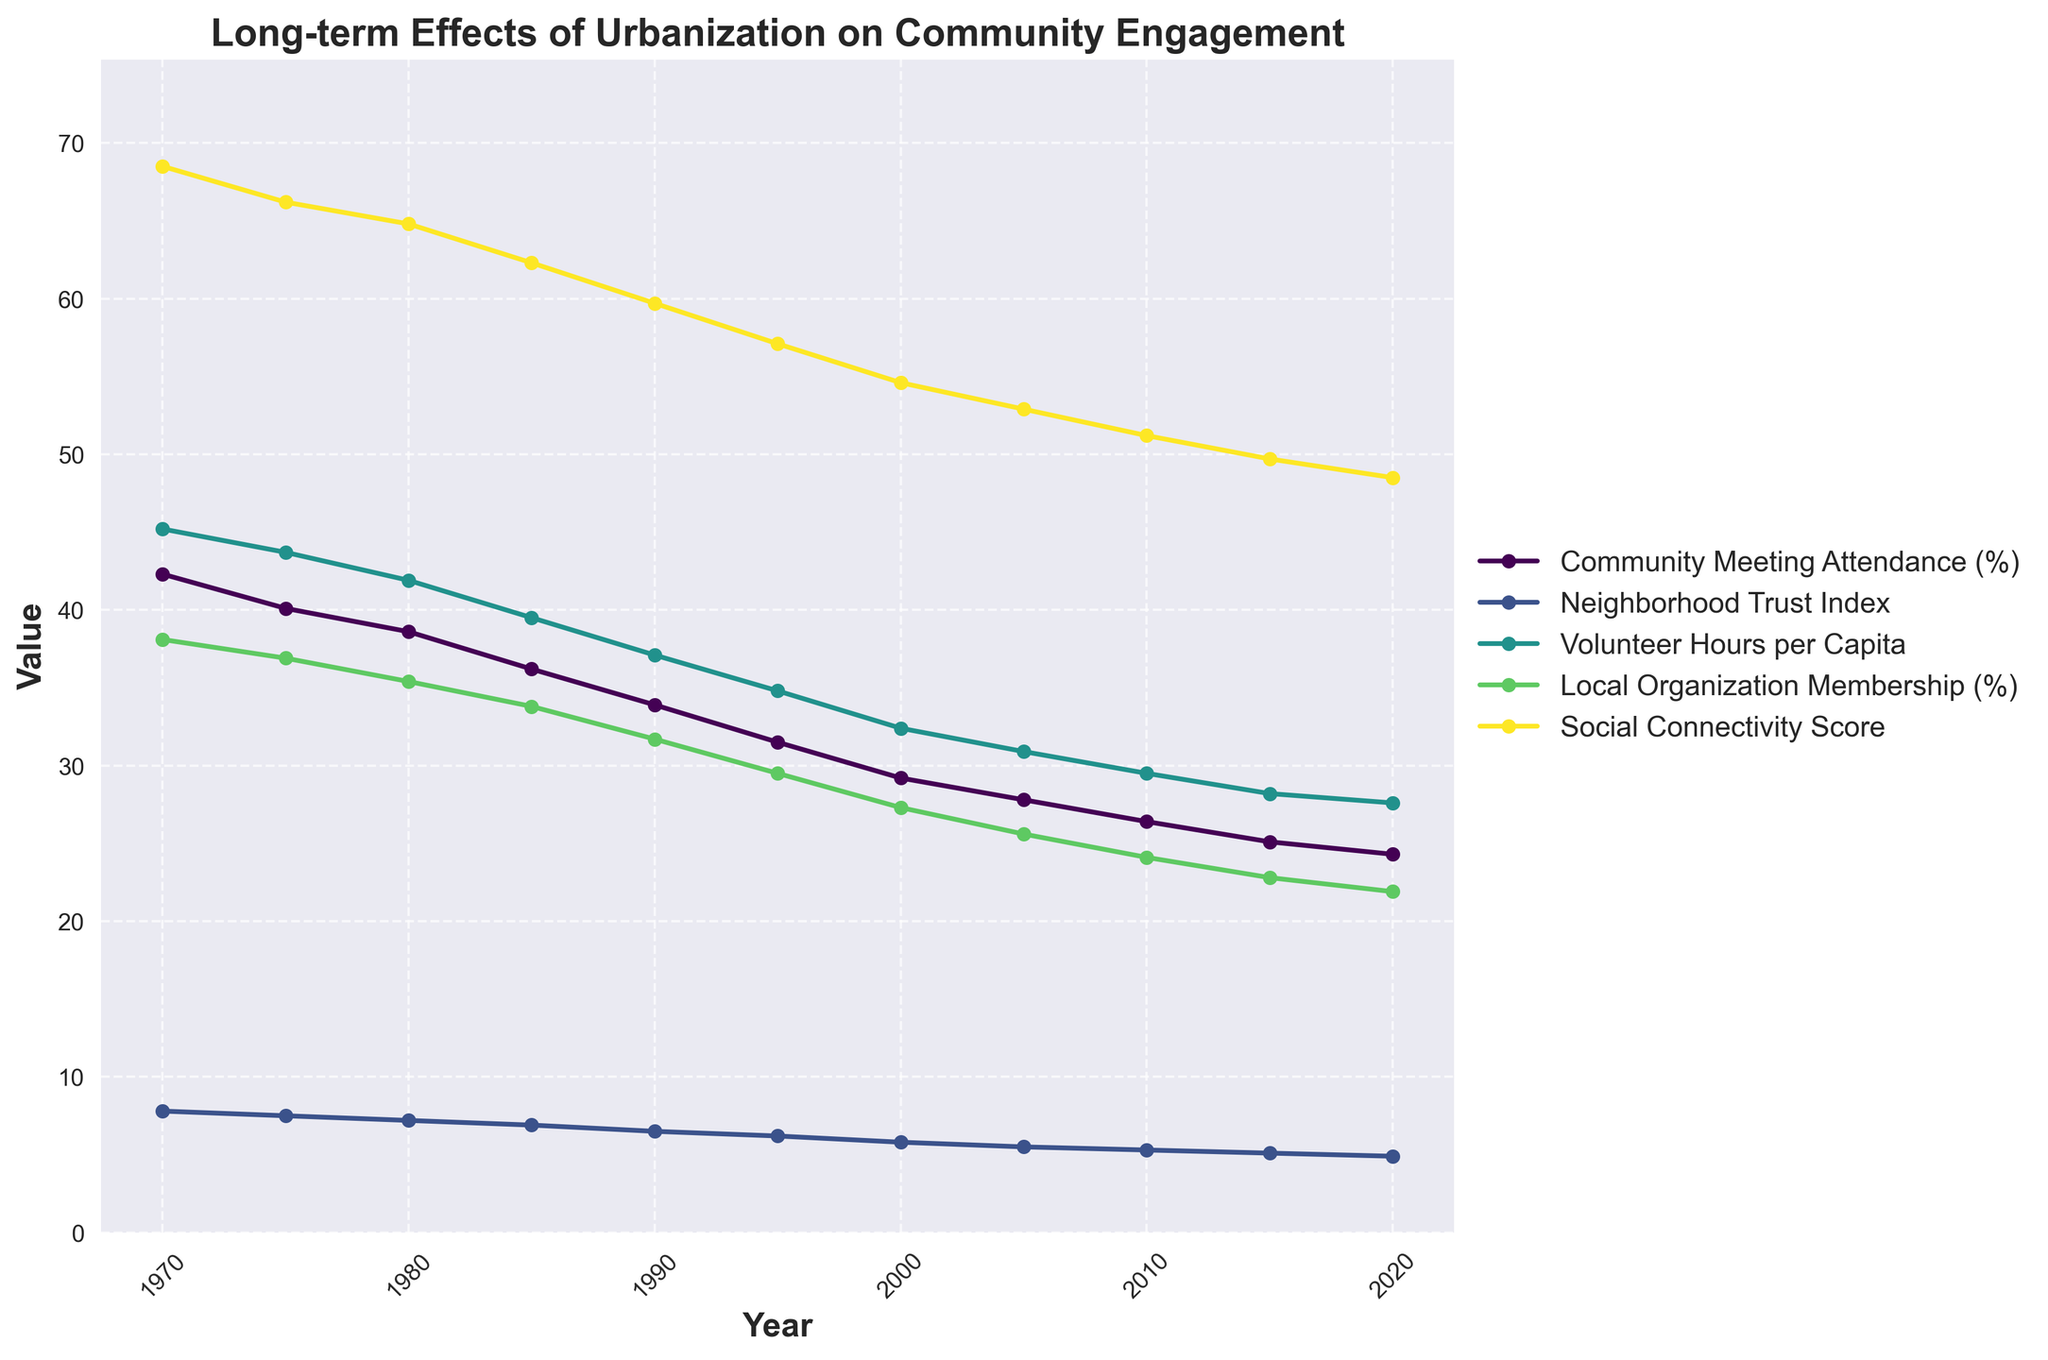What general trend can be observed in Community Meeting Attendance (%) over the years? By looking at the plot, we can see that the Community Meeting Attendance (%) decreases consistently from 1970 to 2020. Although it starts at around 42.3% in 1970, it continuously declines, reaching about 24.3% in 2020.
Answer: Decreasing trend Which metric experienced the steepest decline over the given years? By examining the slopes of the lines, we notice that the Community Meeting Attendance (%) has the steepest negative slope. It decreases the most from about 42.3% in 1970 to 24.3% in 2020.
Answer: Community Meeting Attendance (%) What is the difference in the Social Connectivity Score between 1970 and 2020? The Social Connectivity Score in 1970 is 68.5, and in 2020 it is 48.5. The difference is calculated as 68.5 - 48.5.
Answer: 20 Between which two consecutive years did the Volunteer Hours per Capita see the biggest drop? By finding the differences between consecutive years, we see that the largest decrease in Volunteer Hours per Capita occurs between 1970 (45.2) and 1975 (43.7), giving a difference of 1.5 hours.
Answer: 1970-1975 Which metric remained closest to a linear decline over the years? Observing the consistency of the angles and length between points, the Neighborhood Trust Index appears to have a nearly linear decline compared to other metrics. It uniformly decreases from about 7.8 in 1970 to 4.9 in 2020.
Answer: Neighborhood Trust Index In which year did Local Organization Membership (%) first drop below 30%? According to the plot, the Local Organization Membership (%) drops below 30% for the first time in 1995, where it is recorded as 29.5%.
Answer: 1995 What are the median values for Community Meeting Attendance (%) and Social Connectivity Score? The median is the middle value when data points are ordered. For Community Meeting Attendance, the values are [24.3, 25.1, 26.4, 27.8, 29.2, 31.5, 33.9, 36.2, 38.6, 40.1, 42.3] and the median is 31.5. For Social Connectivity Score, the values are [48.5, 49.7, 51.2, 52.9, 54.6, 57.1, 59.7, 62.3, 64.8, 66.2, 68.5] and the median is 54.6.
Answer: Community Meeting Attendance (%): 31.5, Social Connectivity Score: 54.6 How does the rate of decline in Volunteer Hours per Capita compare to Local Organization Membership (%)? By observing the slopes, both metrics show declines, but the Volunteer Hours per Capita appears to have a sharper drop overall compared to the Local Organization Membership (%), indicating a faster rate of decline.
Answer: Volunteer Hours per Capita declines faster Which two metrics have values that are very close to each other in the year 2020? By examining the intersections and closeness of lines, in 2020, the Community Meeting Attendance (%) is 24.3% and the Local Organization Membership is 21.9%, which are the closest metrics to each other.
Answer: Community Meeting Attendance (%) and Local Organization Membership (%) 